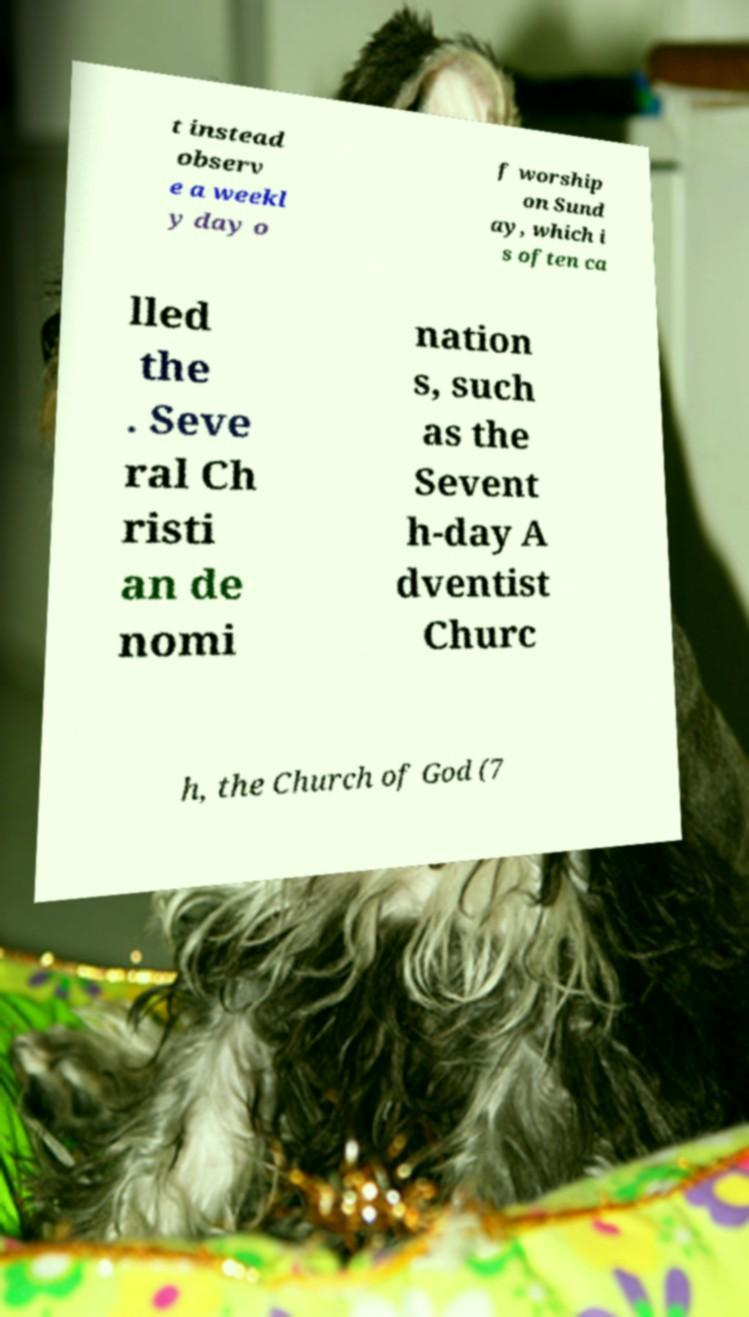Could you extract and type out the text from this image? t instead observ e a weekl y day o f worship on Sund ay, which i s often ca lled the . Seve ral Ch risti an de nomi nation s, such as the Sevent h-day A dventist Churc h, the Church of God (7 